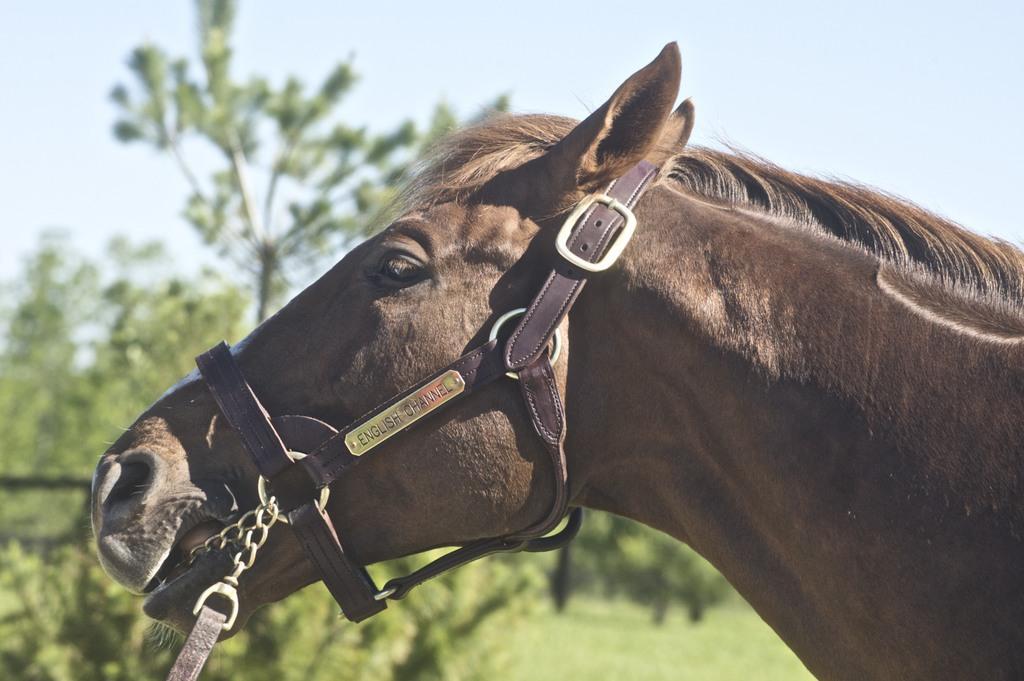Could you give a brief overview of what you see in this image? In this picture we can see a horse and few belts, in the background we can see trees. 